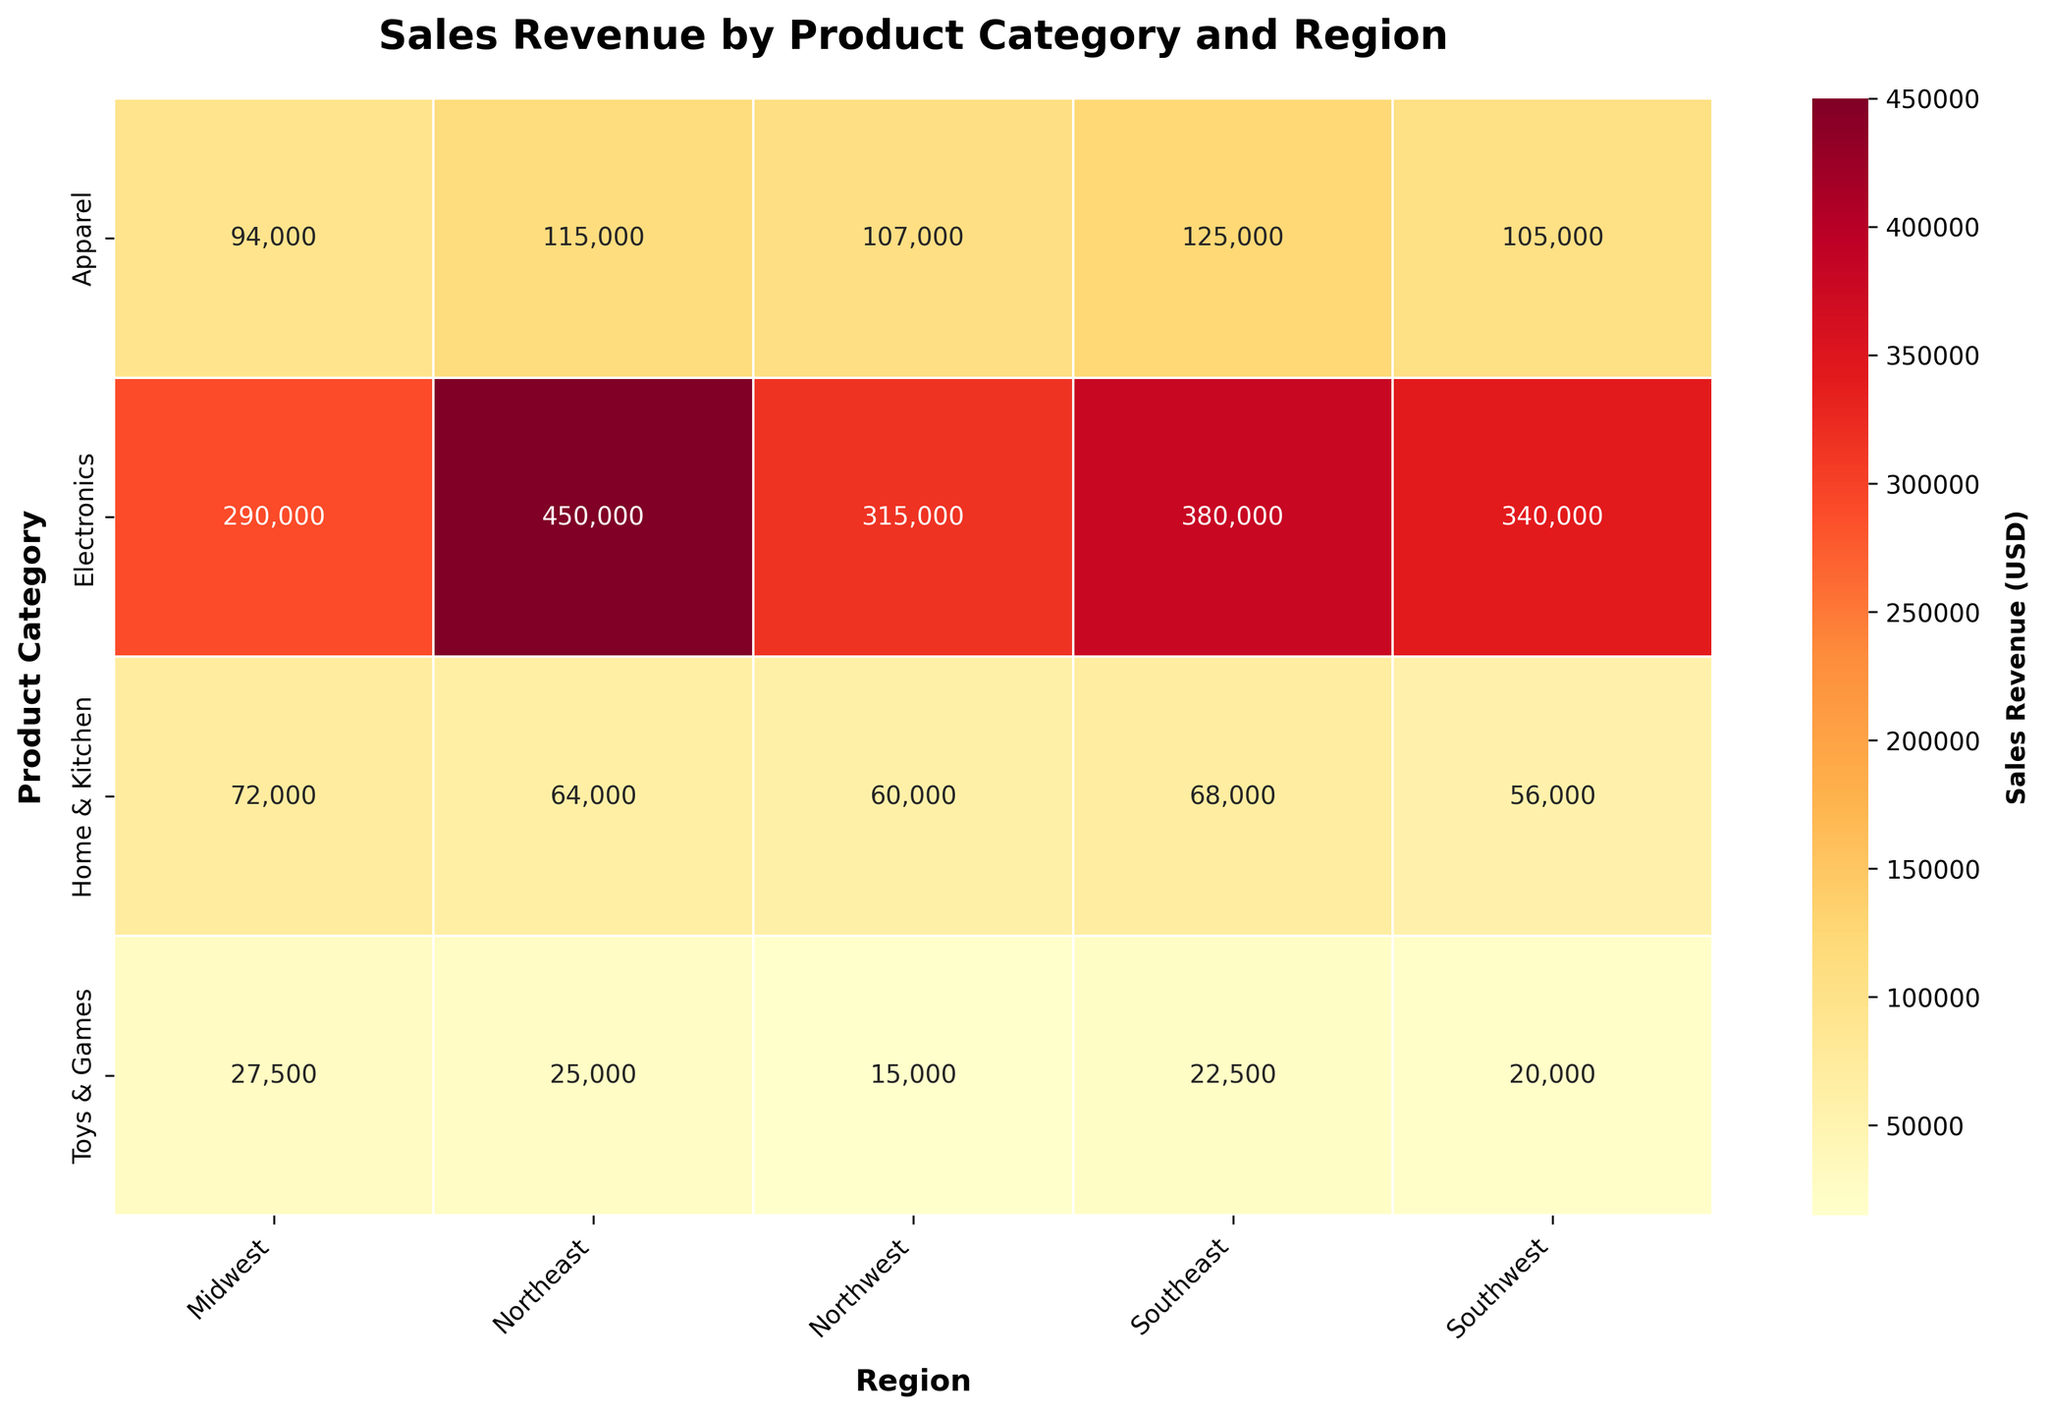What's the title of the figure? The title of the figure is usually located at the top of the heatmap. In this case, it is "Sales Revenue by Product Category and Region" as specified in the code.
Answer: Sales Revenue by Product Category and Region Which region has the highest sales revenue for Electronics? Locate the row for Electronics in the heatmap, then find the cell with the highest value. The highest sales revenue in the Electronics row is found in the Northeast region with a value of 450,000 USD.
Answer: Northeast What is the color associated with the highest sales revenue value? The highest sales revenue value is 450,000 USD in the Northeast region for Electronics. The color associated with this value is found in the top range of the 'YlOrRd' colormap, which is a dark red.
Answer: Dark Red How many categories have sales revenue below 100,000 USD in at least one region? Check each cell in the heatmap for all product categories. For the Apparel, Home & Kitchen, and Toys & Games categories, there are cells with sales revenue below 100,000 USD. Electronics does not have any cell with sales revenue below 100,000 USD.
Answer: Three categories: Apparel, Home & Kitchen, Toys & Games What's the sum of sales revenue for Home & Kitchen across all regions? Add the sales revenue values for Home & Kitchen in all regions: 64,000 + 56,000 + 72,000 + 68,000 + 60,000. The sum is calculated as 320,000 USD.
Answer: 320,000 USD In which region does Apparel have the highest sales revenue and what is the value? Locate the row for Apparel in the heatmap and find the cell with the highest value. The highest value for Apparel is in the Southeast region with a sales revenue of 125,000 USD.
Answer: Southeast, 125,000 USD Is the sales revenue for Electronics in the Midwest greater than that for Apparel in the Northwest? Compare the value for Electronics in the Midwest (290,000 USD) with Apparel in the Northwest (107,000 USD). Since 290,000 > 107,000, the answer is yes.
Answer: Yes Which product category has the most sales revenue in the Southeast region? Locate the column for the Southeast region and find the highest value. The highest value in that column is 380,000 USD, which corresponds to the Electronics category.
Answer: Electronics What’s the average sales revenue for Toys & Games across all regions? Sum the sales revenues for Toys & Games: 25,000 + 20,000 + 27,500 + 22,500 + 15,000. The sum is 110,000 USD. Divide by the number of regions, which is 5. The average is 110,000 / 5 = 22,000 USD.
Answer: 22,000 USD How does the sales revenue for Electronics in the Northeast compare to Home & Kitchen in the Midwest? Compare the value for Electronics in the Northeast (450,000 USD) with Home & Kitchen in the Midwest (72,000 USD). Since 450,000 > 72,000, the answer is that Electronics in the Northeast has a higher sales revenue.
Answer: Electronics in the Northeast has higher sales revenue 